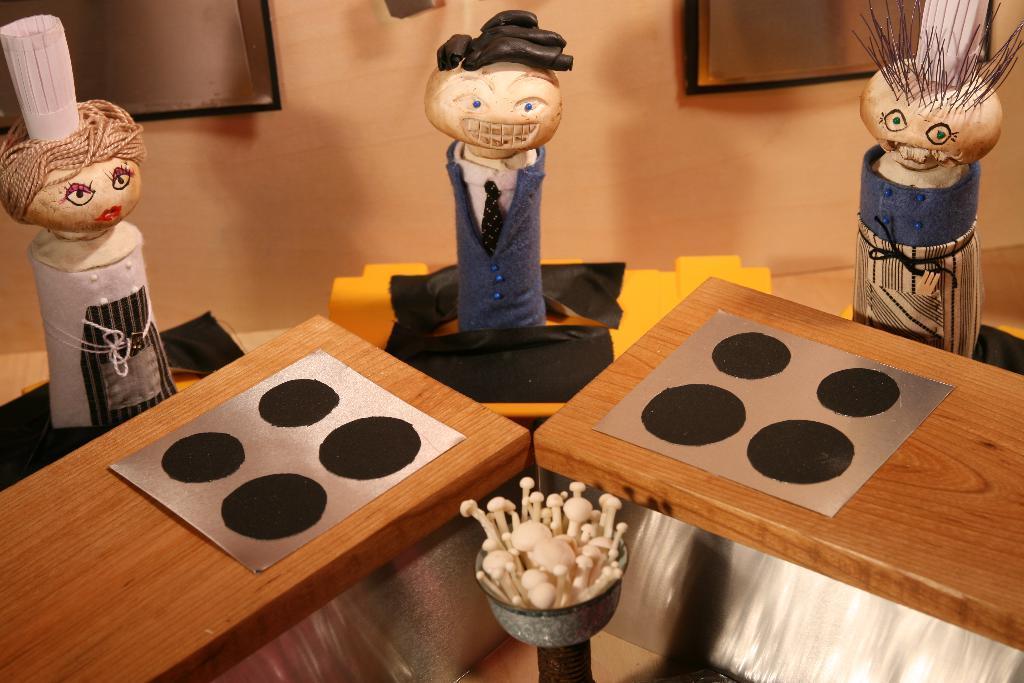How would you summarize this image in a sentence or two? In this image there is a table and we can see figurines placed on the tables. At the bottom there is a bowl containing an object. In the background there is a wall and we can see frames placed on the wall. 